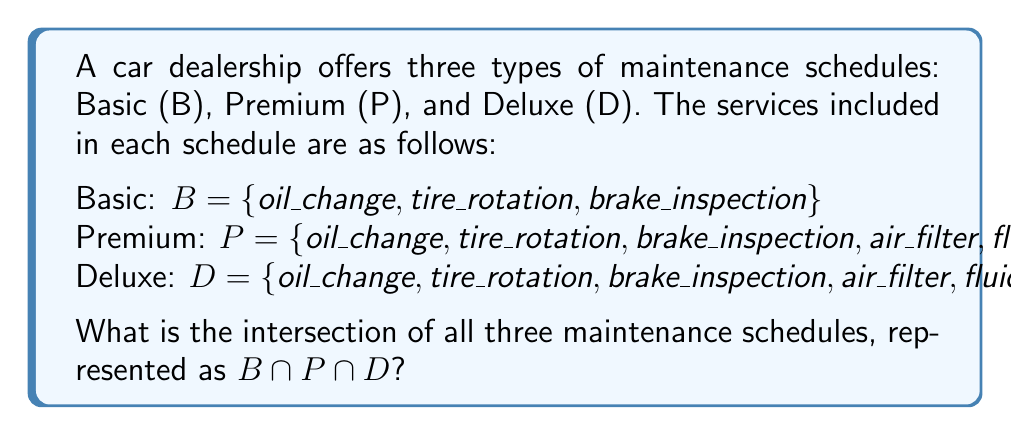Show me your answer to this math problem. To find the intersection of these three sets, we need to identify the elements that are common to all three maintenance schedules.

1. First, let's list out the elements in each set:
   $B = \{oil\_change, tire\_rotation, brake\_inspection\}$
   $P = \{oil\_change, tire\_rotation, brake\_inspection, air\_filter, fluid\_top\_up\}$
   $D = \{oil\_change, tire\_rotation, brake\_inspection, air\_filter, fluid\_top\_up, battery\_check, alignment\}$

2. Now, we need to identify which elements appear in all three sets:
   - $oil\_change$ is in B, P, and D
   - $tire\_rotation$ is in B, P, and D
   - $brake\_inspection$ is in B, P, and D
   - $air\_filter$ is in P and D, but not in B
   - $fluid\_top\_up$ is in P and D, but not in B
   - $battery\_check$ is only in D
   - $alignment$ is only in D

3. The intersection $B \cap P \cap D$ will contain only the elements that are present in all three sets.

Therefore, the intersection of all three maintenance schedules is:
$$B \cap P \cap D = \{oil\_change, tire\_rotation, brake\_inspection\}$$
Answer: $B \cap P \cap D = \{oil\_change, tire\_rotation, brake\_inspection\}$ 